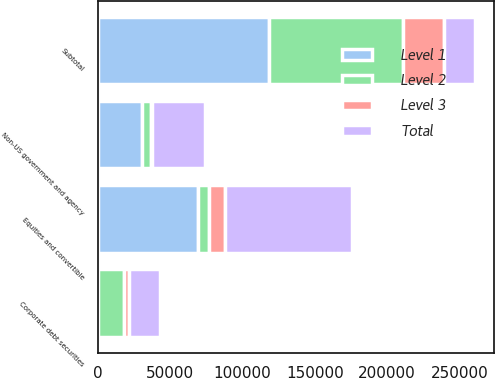Convert chart to OTSL. <chart><loc_0><loc_0><loc_500><loc_500><stacked_bar_chart><ecel><fcel>Non-US government and agency<fcel>Corporate debt securities<fcel>Equities and convertible<fcel>Subtotal<nl><fcel>Level 1<fcel>30255<fcel>249<fcel>68974<fcel>118018<nl><fcel>Level 2<fcel>6668<fcel>17537<fcel>7818<fcel>92700<nl><fcel>Level 3<fcel>136<fcel>3633<fcel>11108<fcel>28650<nl><fcel>Total<fcel>37059<fcel>21419<fcel>87900<fcel>21419<nl></chart> 